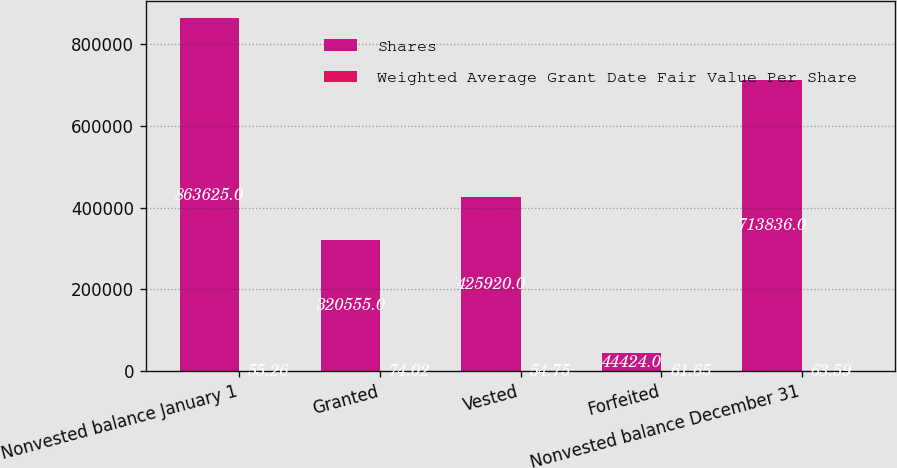Convert chart. <chart><loc_0><loc_0><loc_500><loc_500><stacked_bar_chart><ecel><fcel>Nonvested balance January 1<fcel>Granted<fcel>Vested<fcel>Forfeited<fcel>Nonvested balance December 31<nl><fcel>Shares<fcel>863625<fcel>320555<fcel>425920<fcel>44424<fcel>713836<nl><fcel>Weighted Average Grant Date Fair Value Per Share<fcel>55.26<fcel>74.02<fcel>54.75<fcel>61.65<fcel>63.59<nl></chart> 